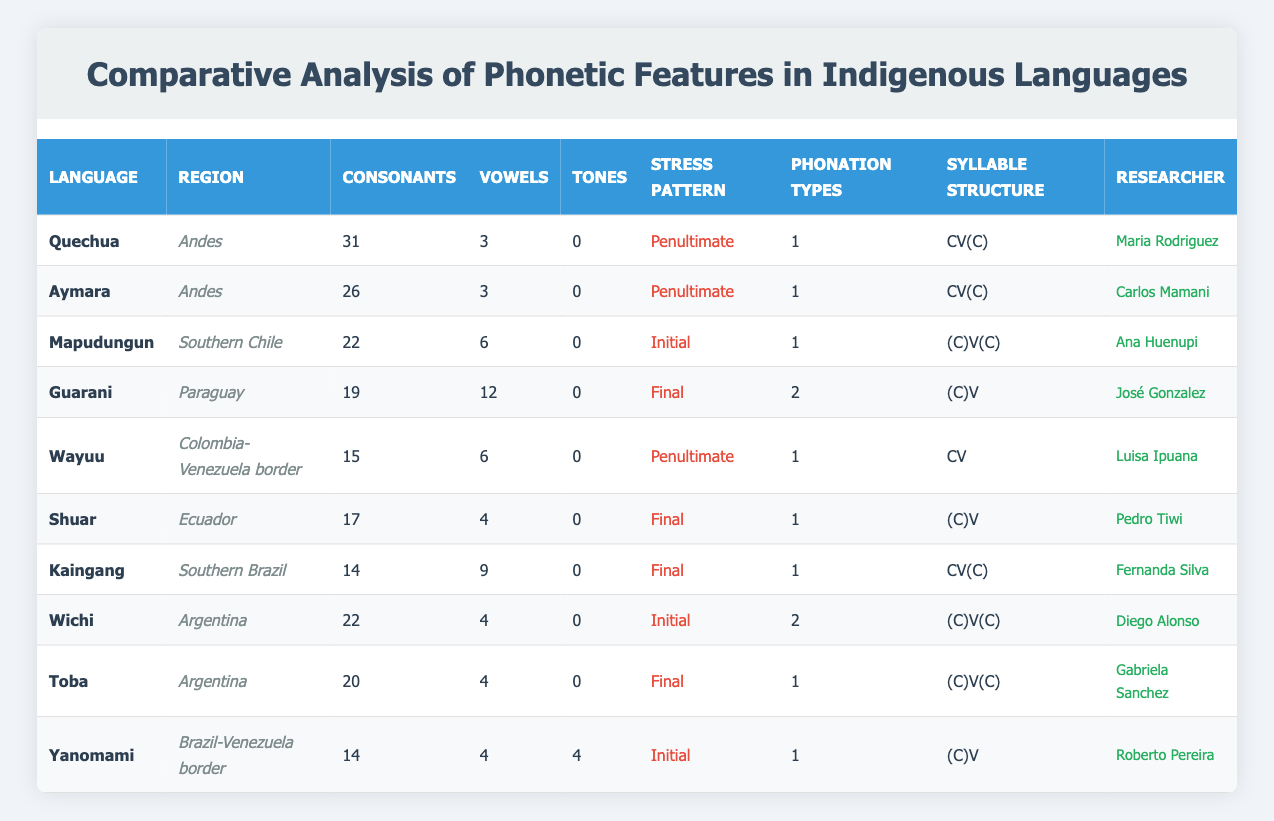What's the language with the highest number of consonants? The language with the highest number of consonants is Quechua, which has 31 consonants. This can be found by comparing all the values in the consonants column of the table.
Answer: Quechua How many vowels does Guarani have? Guarani has 12 vowels. This value is directly retrieved from the vowels column corresponding to the Guarani row.
Answer: 12 Does Wayuu have a final stress pattern? No, Wayuu has a penultimate stress pattern, as indicated in the Stress Pattern column in the corresponding row of the table.
Answer: No What is the average number of vowels across all languages? The total number of vowels is the sum of vowels in each language: 3 + 3 + 6 + 12 + 6 + 4 + 9 + 4 + 4 + 4 = 63. There are 10 languages, so the average number of vowels is 63 / 10 = 6.3.
Answer: 6.3 Which languages have tones? The only language that has tones is Yanomami, which has 4 tones. This information is found by checking the tones column across all languages in the table.
Answer: Yanomami What is the syllable structure of the language with the fewest consonants? The language with the fewest consonants is Kaingang, which has a syllable structure of CV(C). This is found by identifying the minimum value in the consonants column, which is 14 for Kaingang.
Answer: CV(C) How many languages have a penultimate stress pattern? Three languages have a penultimate stress pattern: Quechua, Aymara, and Wayuu. This is determined by counting occurrences of "Penultimate" in the Stress Pattern column.
Answer: 3 What is the maximum number of phonation types found in these languages? The maximum number of phonation types is 2, which occurs in Guarani and Wichi. This can be confirmed by checking the phonation types column for each language and identifying the highest value.
Answer: 2 Is there any language in the dataset with both initial stress and tones? No, there is no language with both initial stress and tones in the dataset. Initial stress can be found in Mapudungun and Yanomami, but only Yanomami has tones, hence no language meets both conditions.
Answer: No 